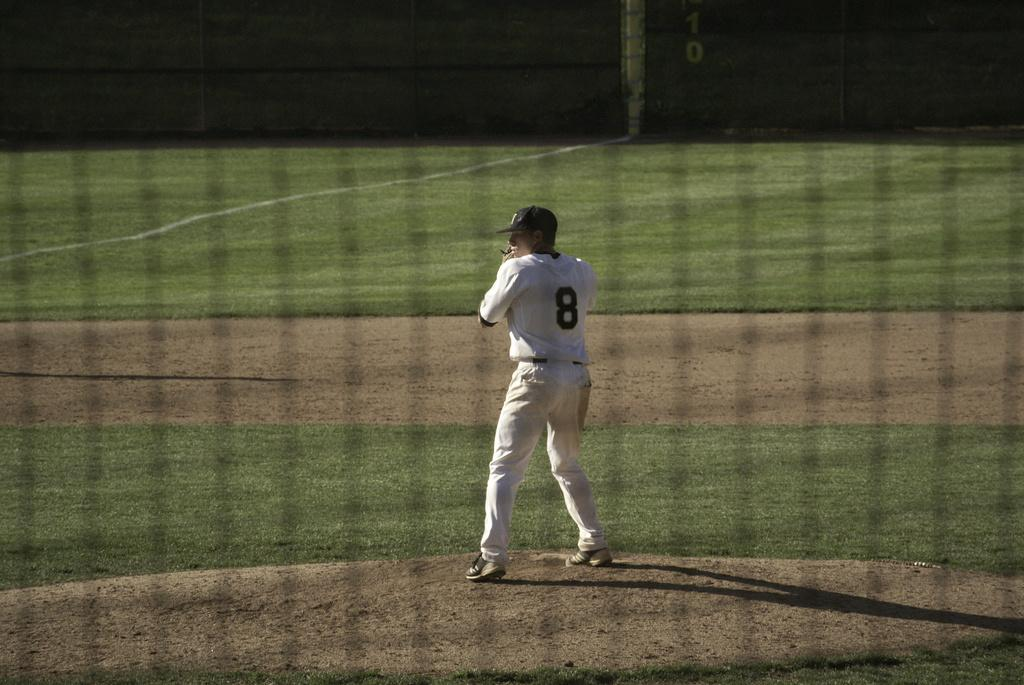What is the main subject of the image? There is a person standing in the image. Where is the person located in the image? The person is in the middle of the image. What type of terrain is visible in the image? There is grass visible in the image. What type of bulb is being used to light up the person's haircut in the image? There is no bulb or haircut present in the image; it features a person standing in the middle of grass. 